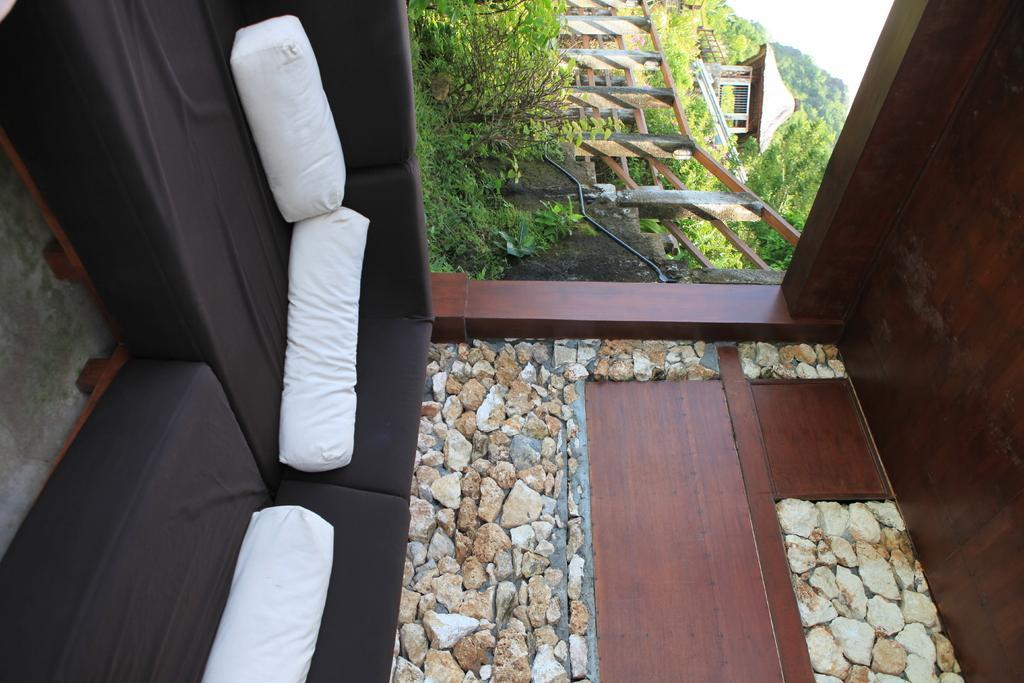Can you describe this image briefly? This is an inside view picture of a wooden house. We can see pebbles, sofa and white pillows. we can see the fence and plants. Far we can see a wooden house, trees. 